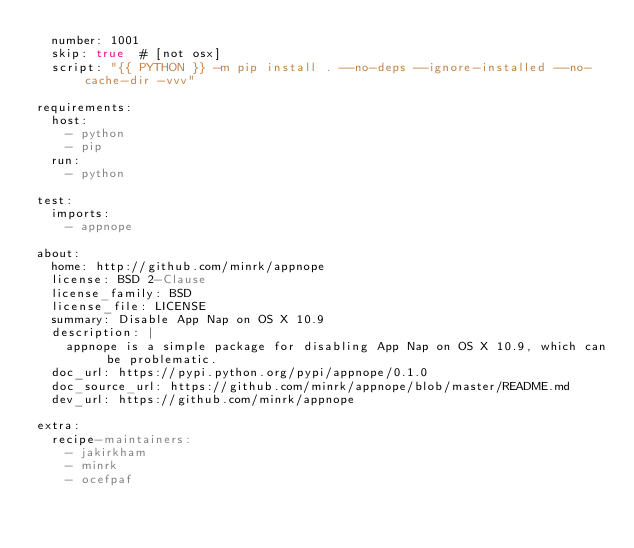Convert code to text. <code><loc_0><loc_0><loc_500><loc_500><_YAML_>  number: 1001
  skip: true  # [not osx]
  script: "{{ PYTHON }} -m pip install . --no-deps --ignore-installed --no-cache-dir -vvv"

requirements:
  host:
    - python
    - pip
  run:
    - python

test:
  imports:
    - appnope

about:
  home: http://github.com/minrk/appnope
  license: BSD 2-Clause
  license_family: BSD
  license_file: LICENSE
  summary: Disable App Nap on OS X 10.9
  description: |
    appnope is a simple package for disabling App Nap on OS X 10.9, which can be problematic.
  doc_url: https://pypi.python.org/pypi/appnope/0.1.0
  doc_source_url: https://github.com/minrk/appnope/blob/master/README.md
  dev_url: https://github.com/minrk/appnope

extra:
  recipe-maintainers:
    - jakirkham
    - minrk
    - ocefpaf
</code> 